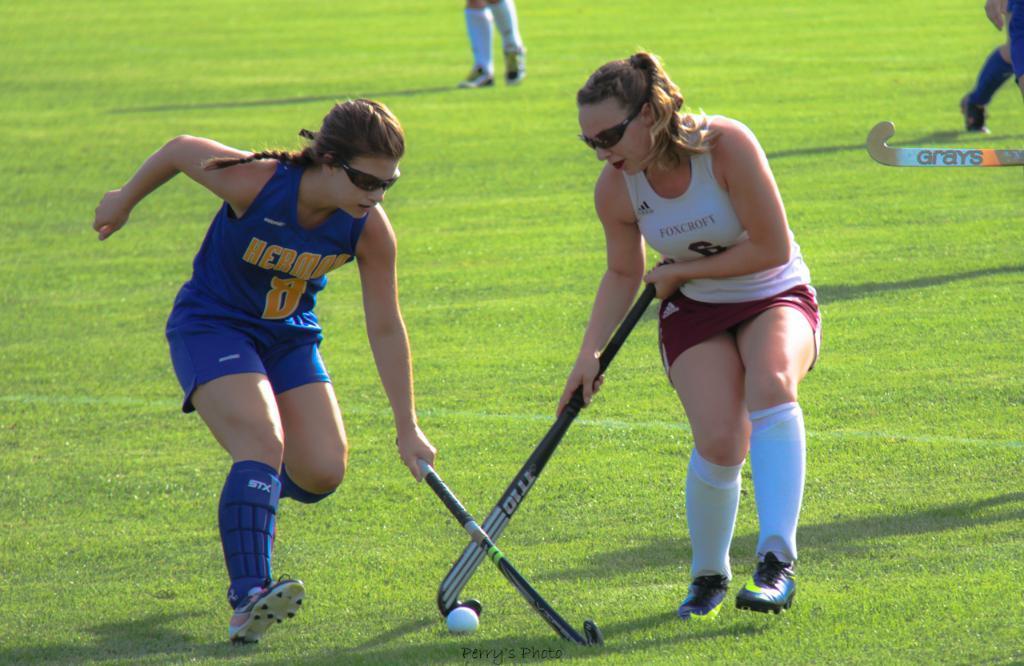Please provide a concise description of this image. In this image we can see a few people playing hockey on the ground. 